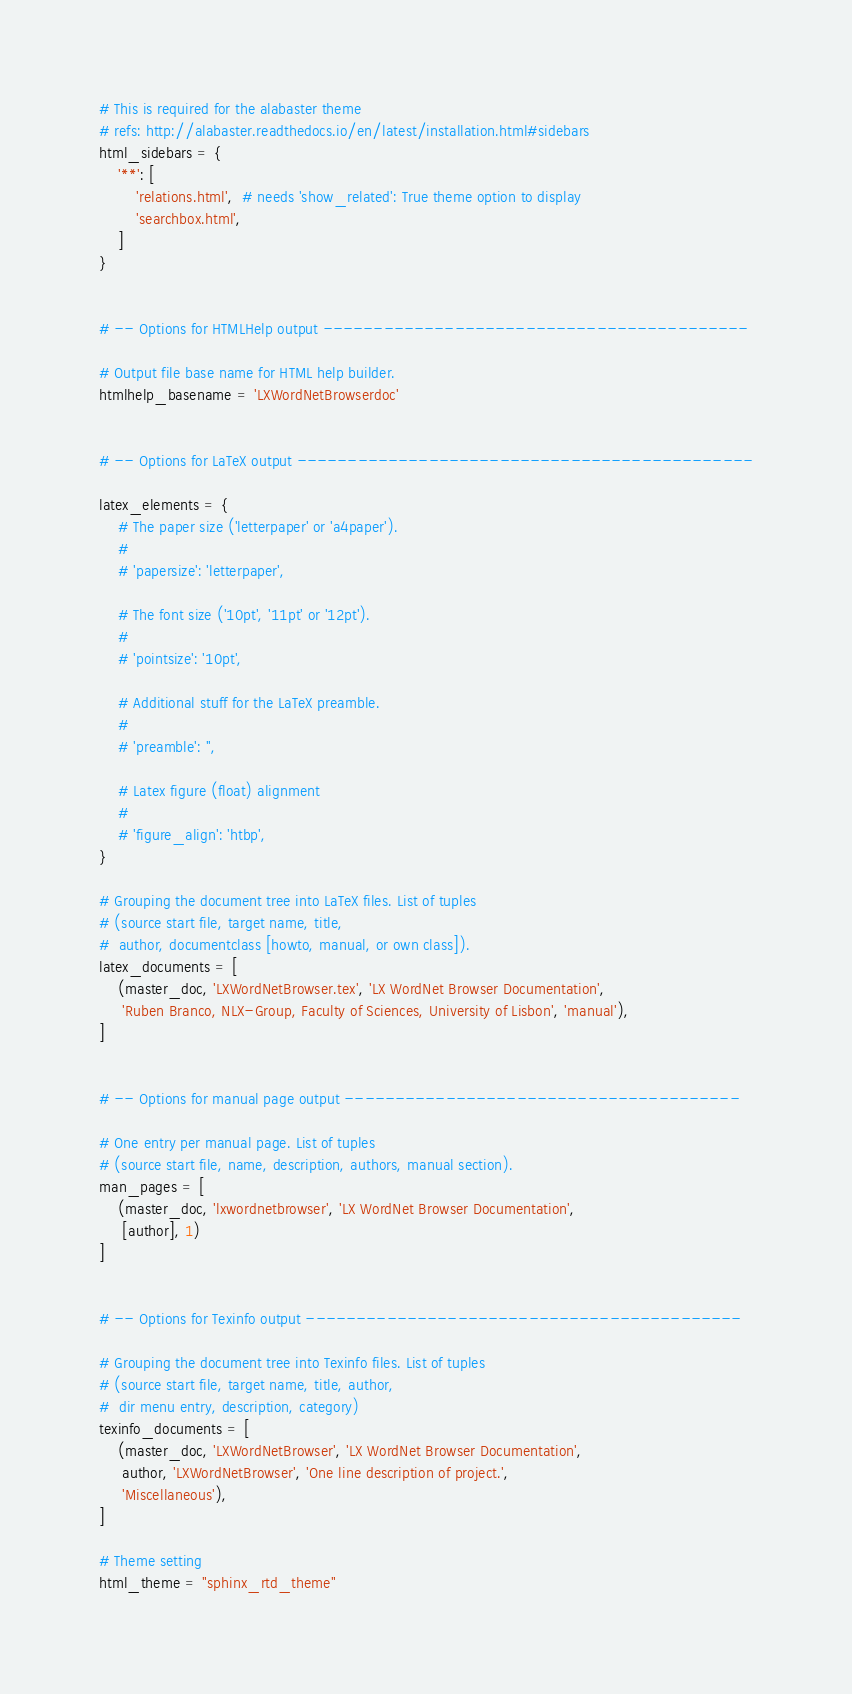Convert code to text. <code><loc_0><loc_0><loc_500><loc_500><_Python_># This is required for the alabaster theme
# refs: http://alabaster.readthedocs.io/en/latest/installation.html#sidebars
html_sidebars = {
    '**': [
        'relations.html',  # needs 'show_related': True theme option to display
        'searchbox.html',
    ]
}


# -- Options for HTMLHelp output ------------------------------------------

# Output file base name for HTML help builder.
htmlhelp_basename = 'LXWordNetBrowserdoc'


# -- Options for LaTeX output ---------------------------------------------

latex_elements = {
    # The paper size ('letterpaper' or 'a4paper').
    #
    # 'papersize': 'letterpaper',

    # The font size ('10pt', '11pt' or '12pt').
    #
    # 'pointsize': '10pt',

    # Additional stuff for the LaTeX preamble.
    #
    # 'preamble': '',

    # Latex figure (float) alignment
    #
    # 'figure_align': 'htbp',
}

# Grouping the document tree into LaTeX files. List of tuples
# (source start file, target name, title,
#  author, documentclass [howto, manual, or own class]).
latex_documents = [
    (master_doc, 'LXWordNetBrowser.tex', 'LX WordNet Browser Documentation',
     'Ruben Branco, NLX-Group, Faculty of Sciences, University of Lisbon', 'manual'),
]


# -- Options for manual page output ---------------------------------------

# One entry per manual page. List of tuples
# (source start file, name, description, authors, manual section).
man_pages = [
    (master_doc, 'lxwordnetbrowser', 'LX WordNet Browser Documentation',
     [author], 1)
]


# -- Options for Texinfo output -------------------------------------------

# Grouping the document tree into Texinfo files. List of tuples
# (source start file, target name, title, author,
#  dir menu entry, description, category)
texinfo_documents = [
    (master_doc, 'LXWordNetBrowser', 'LX WordNet Browser Documentation',
     author, 'LXWordNetBrowser', 'One line description of project.',
     'Miscellaneous'),
]

# Theme setting
html_theme = "sphinx_rtd_theme"




</code> 